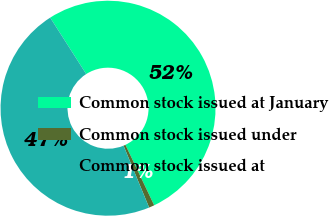Convert chart. <chart><loc_0><loc_0><loc_500><loc_500><pie_chart><fcel>Common stock issued at January<fcel>Common stock issued under<fcel>Common stock issued at<nl><fcel>51.98%<fcel>0.82%<fcel>47.2%<nl></chart> 